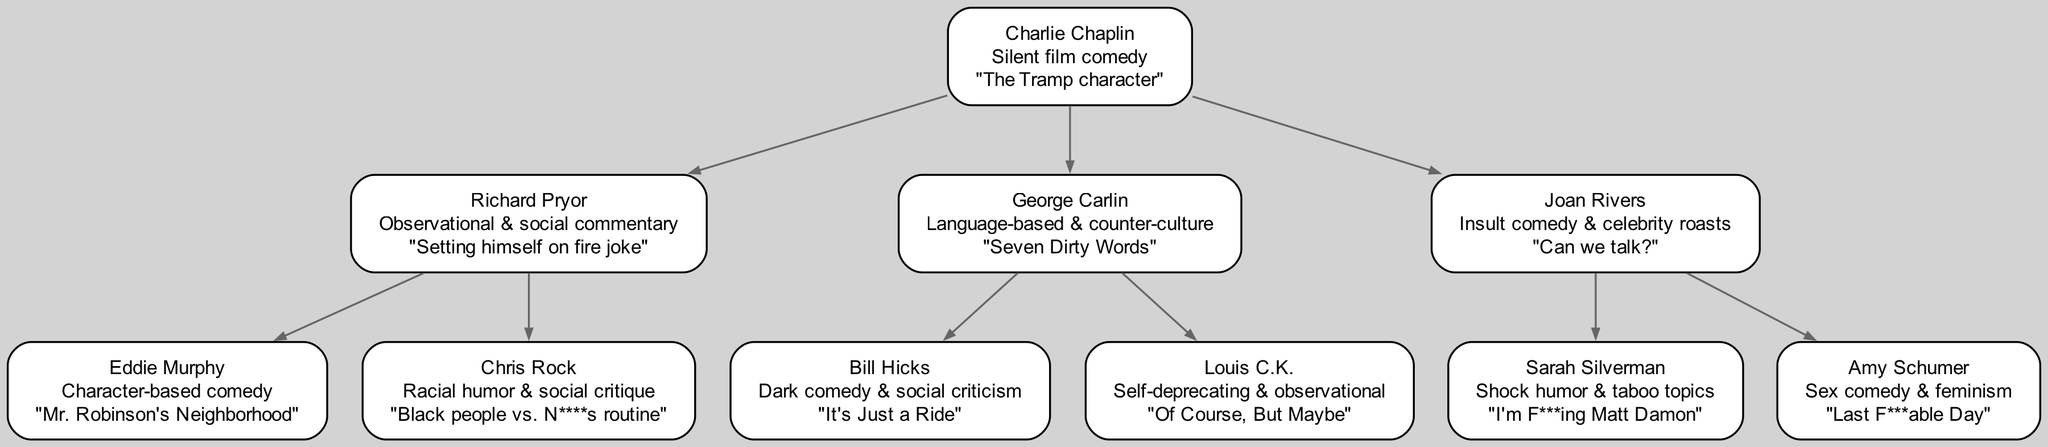What is the comedic style of Richard Pryor? The diagram indicates that Richard Pryor's comedic style is "Observational & social commentary," which is directly listed under his name in the family tree.
Answer: Observational & social commentary Who is the child of Joan Rivers? According to the diagram, Joan Rivers has two children listed, Sarah Silverman and Amy Schumer. Any one of them answers the question, but since both are valid responses, I can focus on one. In this case, Sarah Silverman is the first one listed.
Answer: Sarah Silverman How many comedians are children of George Carlin? The diagram shows that George Carlin has two children listed, Bill Hicks and Louis C.K. By counting the number of children nodes connected to George Carlin, we arrive at the total.
Answer: 2 Which comedian is known for the "Last F***able Day" joke? By examining the diagram, we see that Amy Schumer is the comedian associated with the "Last F***able Day" signature joke. This information can be found directly under her name.
Answer: Amy Schumer What is the relationship between Charlie Chaplin and Eddie Murphy? The diagram shows that Charlie Chaplin is the parent node of Richard Pryor, who is then the parent of Eddie Murphy, meaning Charlie Chaplin is the grandparent of Eddie Murphy. This hierarchical relationship specifies their familial position in the comedic lineage.
Answer: Grandparent Which signature joke is associated with Chris Rock? In the diagram, Chris Rock’s signature joke is listed as "Black people vs. N****s routine." This signature joke is presented directly beneath Chris Rock’s name.
Answer: Black people vs. N****s routine What style of comedy is Bill Hicks known for? The diagram specifies Bill Hicks's comedic style as "Dark comedy & social criticism," which is presented as part of his node's information.
Answer: Dark comedy & social criticism How many total comedians are represented in the diagram? By counting all the nodes, including the root, children, and grandchildren, we find the total number of comedians represented. The root comedian, Charlie Chaplin, plus his five children and grandchildren, gives us six in total.
Answer: 6 